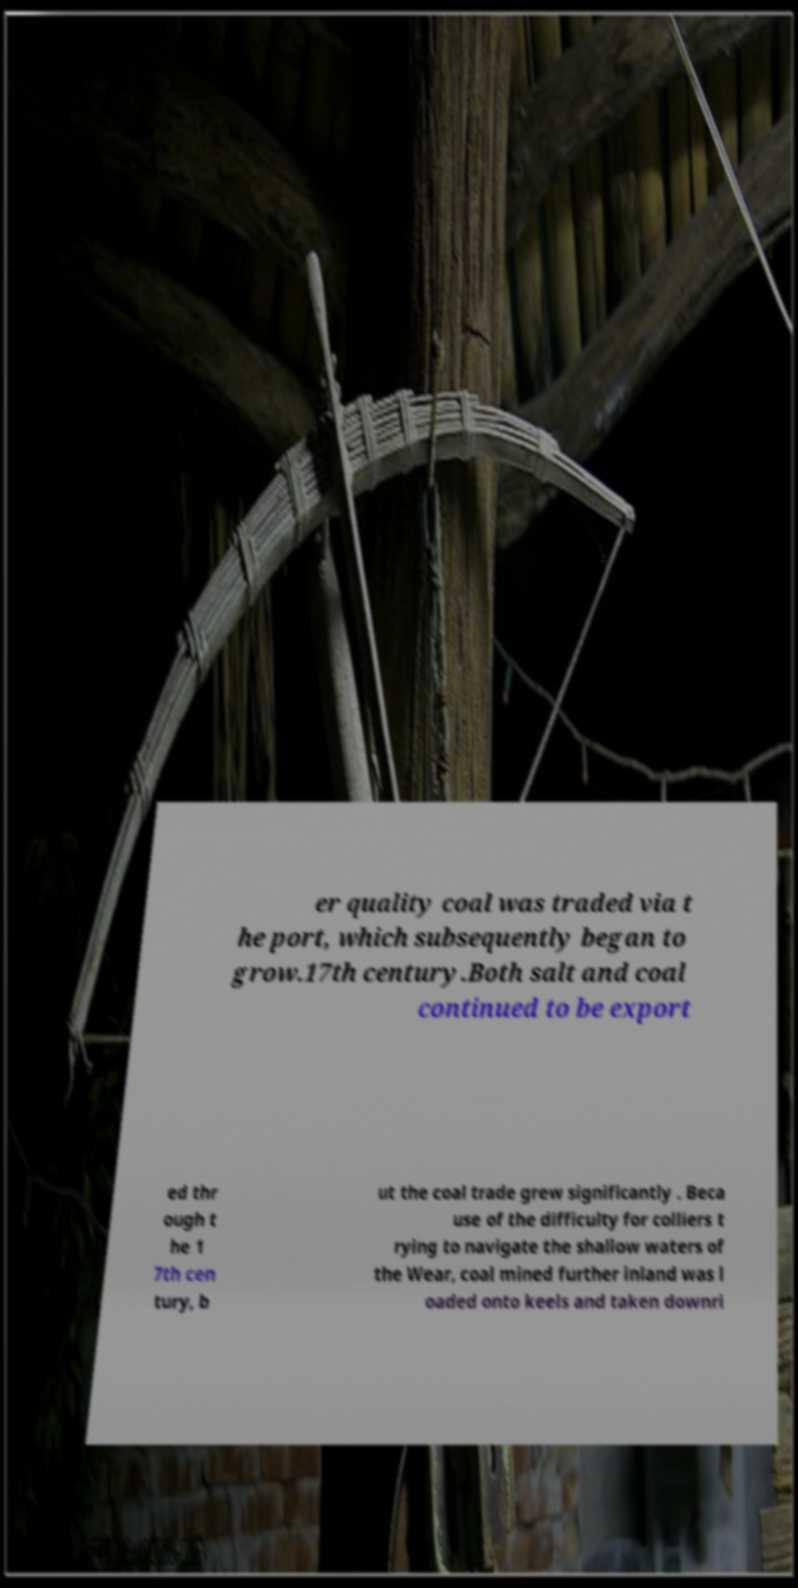What messages or text are displayed in this image? I need them in a readable, typed format. er quality coal was traded via t he port, which subsequently began to grow.17th century.Both salt and coal continued to be export ed thr ough t he 1 7th cen tury, b ut the coal trade grew significantly . Beca use of the difficulty for colliers t rying to navigate the shallow waters of the Wear, coal mined further inland was l oaded onto keels and taken downri 